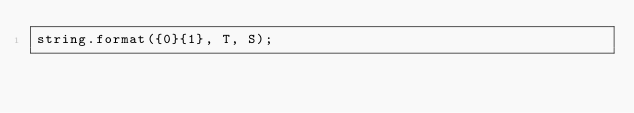<code> <loc_0><loc_0><loc_500><loc_500><_C#_>string.format({0}{1}, T, S);</code> 